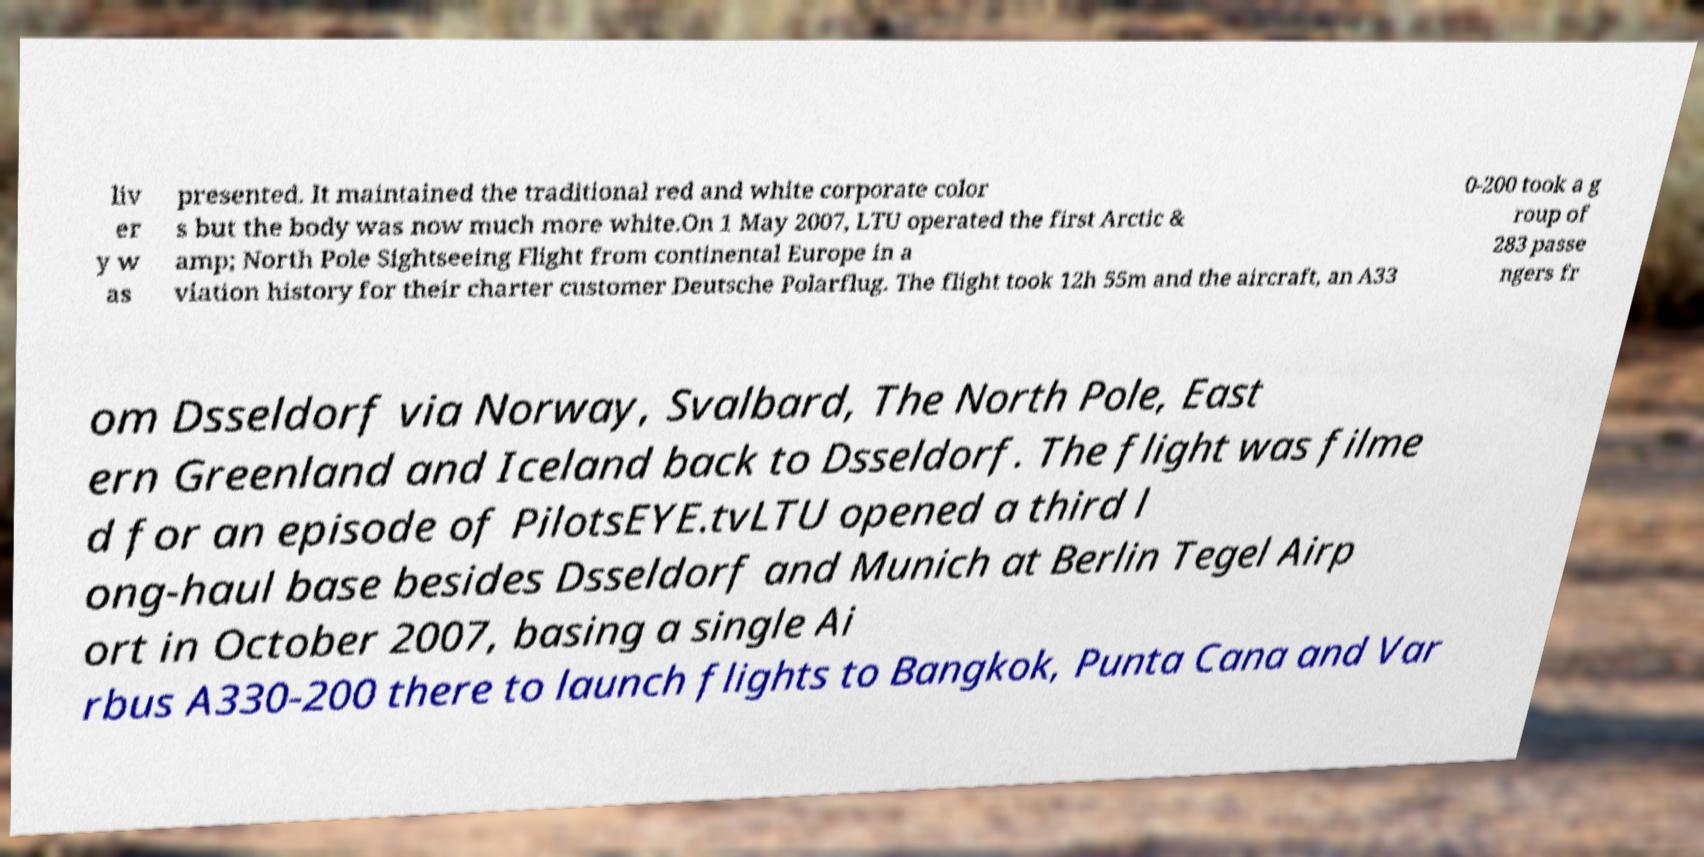There's text embedded in this image that I need extracted. Can you transcribe it verbatim? liv er y w as presented. It maintained the traditional red and white corporate color s but the body was now much more white.On 1 May 2007, LTU operated the first Arctic & amp; North Pole Sightseeing Flight from continental Europe in a viation history for their charter customer Deutsche Polarflug. The flight took 12h 55m and the aircraft, an A33 0-200 took a g roup of 283 passe ngers fr om Dsseldorf via Norway, Svalbard, The North Pole, East ern Greenland and Iceland back to Dsseldorf. The flight was filme d for an episode of PilotsEYE.tvLTU opened a third l ong-haul base besides Dsseldorf and Munich at Berlin Tegel Airp ort in October 2007, basing a single Ai rbus A330-200 there to launch flights to Bangkok, Punta Cana and Var 